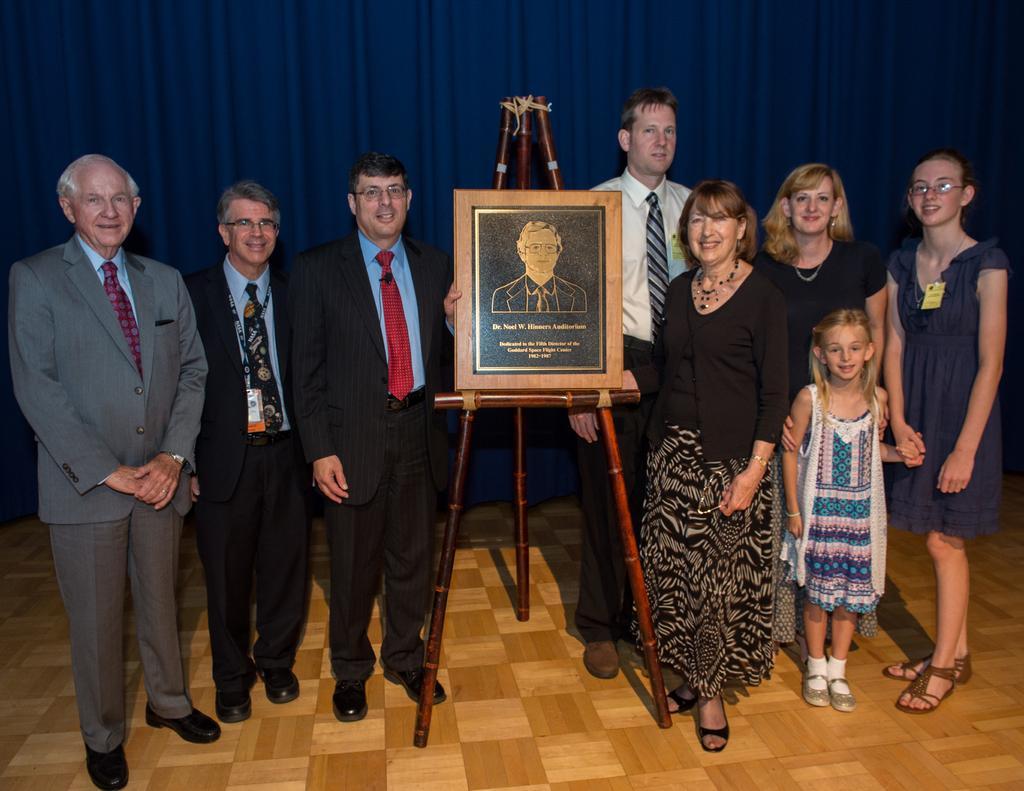Could you give a brief overview of what you see in this image? In this picture we can see a group of people on the floor, here we can see a board on the table and in the background we can see a curtain. 